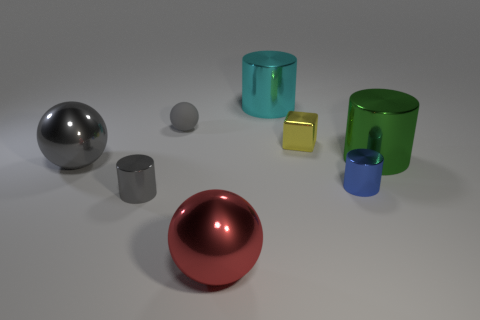Add 1 gray things. How many objects exist? 9 Subtract all spheres. How many objects are left? 5 Subtract 0 red blocks. How many objects are left? 8 Subtract all gray metal balls. Subtract all gray metallic balls. How many objects are left? 6 Add 1 tiny blocks. How many tiny blocks are left? 2 Add 5 red balls. How many red balls exist? 6 